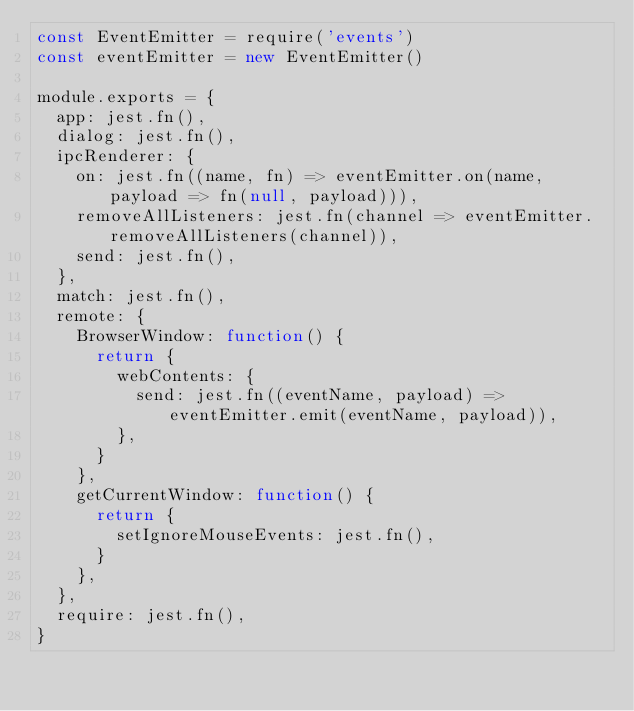Convert code to text. <code><loc_0><loc_0><loc_500><loc_500><_JavaScript_>const EventEmitter = require('events')
const eventEmitter = new EventEmitter()

module.exports = {
  app: jest.fn(),
  dialog: jest.fn(),
  ipcRenderer: {
    on: jest.fn((name, fn) => eventEmitter.on(name, payload => fn(null, payload))),
    removeAllListeners: jest.fn(channel => eventEmitter.removeAllListeners(channel)),
    send: jest.fn(),
  },
  match: jest.fn(),
  remote: {
    BrowserWindow: function() {
      return {
        webContents: {
          send: jest.fn((eventName, payload) => eventEmitter.emit(eventName, payload)),
        },
      }
    },
    getCurrentWindow: function() {
      return {
        setIgnoreMouseEvents: jest.fn(),
      }
    },
  },
  require: jest.fn(),
}
</code> 